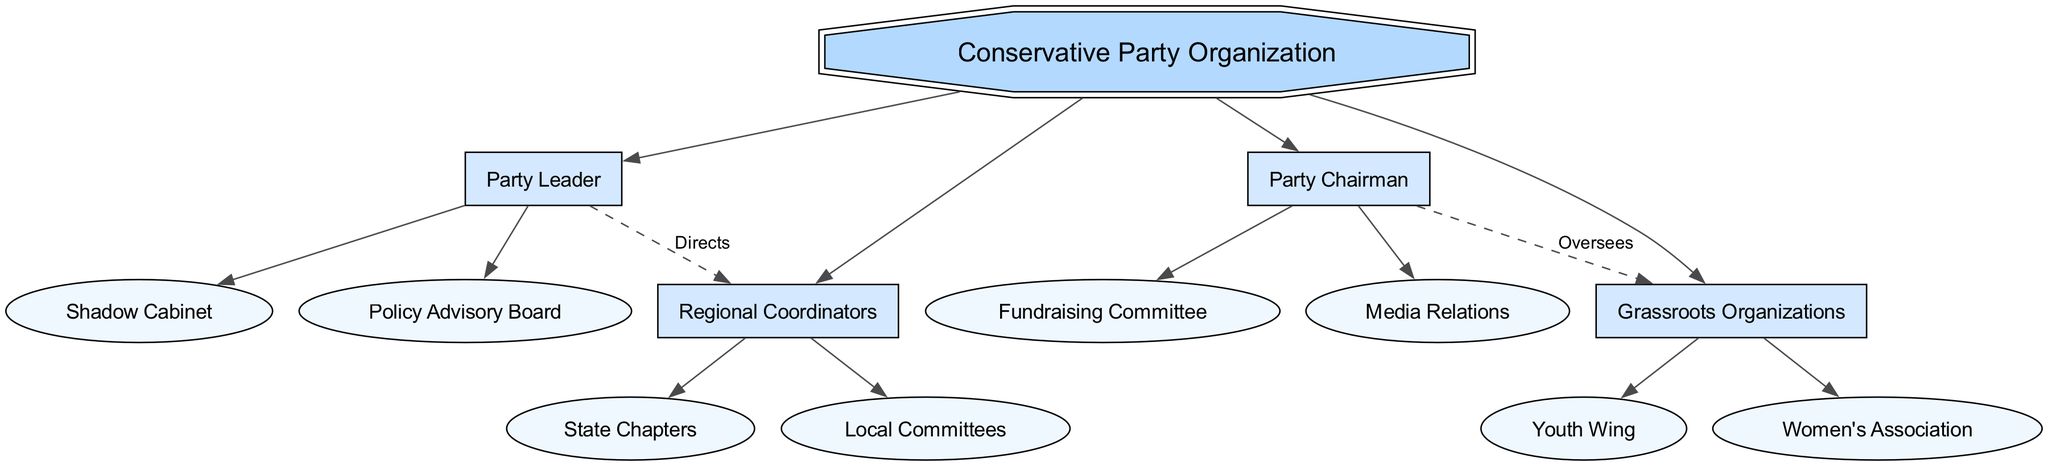What is the root of the diagram? The root of the diagram is labeled "National Executive Committee." This is the top-level node in the hierarchical structure.
Answer: National Executive Committee How many main branches are there? The diagram contains four main branches extending from the root node, representing different roles within the party organization.
Answer: 4 What does the Party Leader direct? According to the connections in the diagram, the Party Leader directs the Regional Coordinators, establishing a line of authority from the leader to this group.
Answer: Regional Coordinators Which committee does the Party Chairman oversee? The diagram shows that the Party Chairman oversees the Grassroots Organizations. This connection indicates a supervisory relationship.
Answer: Grassroots Organizations How many children does the Party Leader have? The Party Leader has two children in the diagram: the Shadow Cabinet and the Policy Advisory Board. This indicates his responsibilities extend to these two groups.
Answer: 2 What type of diagram is this? The diagram is a hierarchical structure, as it visually represents the organization’s levels and relationships in a tree-like format.
Answer: Hierarchical Which node directly connects to the Media Relations? Media Relations is connected as a child of the Party Chairman, indicating that the Party Chairman has a direct oversight role over this node.
Answer: Party Chairman Who is below the Party Chairman in the hierarchy? The children of the Party Chairman in the diagram are the Fundraising Committee and Media Relations, showing the immediate subordination under the chairman's role.
Answer: Fundraising Committee and Media Relations What is the color of the root node? The root node is displayed in a distinct color, specifically a different shade to symbolize its significance, which is blue according to the diagram characteristics.
Answer: Blue 